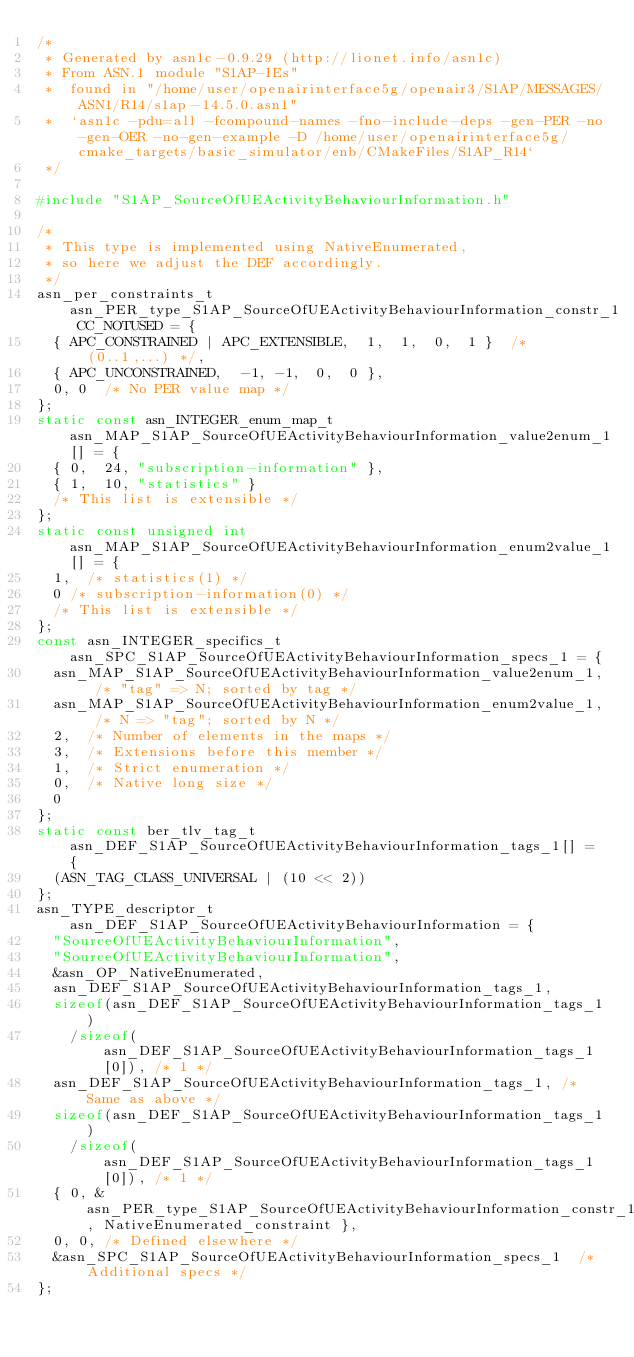<code> <loc_0><loc_0><loc_500><loc_500><_C_>/*
 * Generated by asn1c-0.9.29 (http://lionet.info/asn1c)
 * From ASN.1 module "S1AP-IEs"
 * 	found in "/home/user/openairinterface5g/openair3/S1AP/MESSAGES/ASN1/R14/s1ap-14.5.0.asn1"
 * 	`asn1c -pdu=all -fcompound-names -fno-include-deps -gen-PER -no-gen-OER -no-gen-example -D /home/user/openairinterface5g/cmake_targets/basic_simulator/enb/CMakeFiles/S1AP_R14`
 */

#include "S1AP_SourceOfUEActivityBehaviourInformation.h"

/*
 * This type is implemented using NativeEnumerated,
 * so here we adjust the DEF accordingly.
 */
asn_per_constraints_t asn_PER_type_S1AP_SourceOfUEActivityBehaviourInformation_constr_1 CC_NOTUSED = {
	{ APC_CONSTRAINED | APC_EXTENSIBLE,  1,  1,  0,  1 }	/* (0..1,...) */,
	{ APC_UNCONSTRAINED,	-1, -1,  0,  0 },
	0, 0	/* No PER value map */
};
static const asn_INTEGER_enum_map_t asn_MAP_S1AP_SourceOfUEActivityBehaviourInformation_value2enum_1[] = {
	{ 0,	24,	"subscription-information" },
	{ 1,	10,	"statistics" }
	/* This list is extensible */
};
static const unsigned int asn_MAP_S1AP_SourceOfUEActivityBehaviourInformation_enum2value_1[] = {
	1,	/* statistics(1) */
	0	/* subscription-information(0) */
	/* This list is extensible */
};
const asn_INTEGER_specifics_t asn_SPC_S1AP_SourceOfUEActivityBehaviourInformation_specs_1 = {
	asn_MAP_S1AP_SourceOfUEActivityBehaviourInformation_value2enum_1,	/* "tag" => N; sorted by tag */
	asn_MAP_S1AP_SourceOfUEActivityBehaviourInformation_enum2value_1,	/* N => "tag"; sorted by N */
	2,	/* Number of elements in the maps */
	3,	/* Extensions before this member */
	1,	/* Strict enumeration */
	0,	/* Native long size */
	0
};
static const ber_tlv_tag_t asn_DEF_S1AP_SourceOfUEActivityBehaviourInformation_tags_1[] = {
	(ASN_TAG_CLASS_UNIVERSAL | (10 << 2))
};
asn_TYPE_descriptor_t asn_DEF_S1AP_SourceOfUEActivityBehaviourInformation = {
	"SourceOfUEActivityBehaviourInformation",
	"SourceOfUEActivityBehaviourInformation",
	&asn_OP_NativeEnumerated,
	asn_DEF_S1AP_SourceOfUEActivityBehaviourInformation_tags_1,
	sizeof(asn_DEF_S1AP_SourceOfUEActivityBehaviourInformation_tags_1)
		/sizeof(asn_DEF_S1AP_SourceOfUEActivityBehaviourInformation_tags_1[0]), /* 1 */
	asn_DEF_S1AP_SourceOfUEActivityBehaviourInformation_tags_1,	/* Same as above */
	sizeof(asn_DEF_S1AP_SourceOfUEActivityBehaviourInformation_tags_1)
		/sizeof(asn_DEF_S1AP_SourceOfUEActivityBehaviourInformation_tags_1[0]), /* 1 */
	{ 0, &asn_PER_type_S1AP_SourceOfUEActivityBehaviourInformation_constr_1, NativeEnumerated_constraint },
	0, 0,	/* Defined elsewhere */
	&asn_SPC_S1AP_SourceOfUEActivityBehaviourInformation_specs_1	/* Additional specs */
};

</code> 